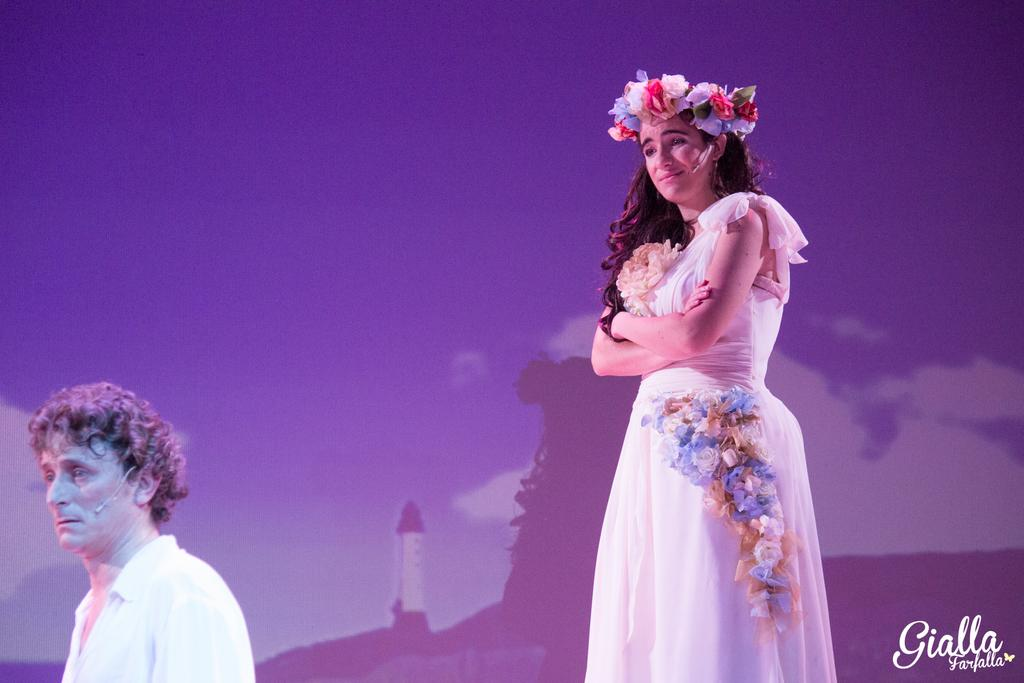How many people are present in the image? There are two people in the image. Can you describe the attire or accessories of one of the people? One person is wearing a crown. What type of meal are the women preparing in the image? There is no information about a meal or women in the image; it only mentions two people, one of whom is wearing a crown. 